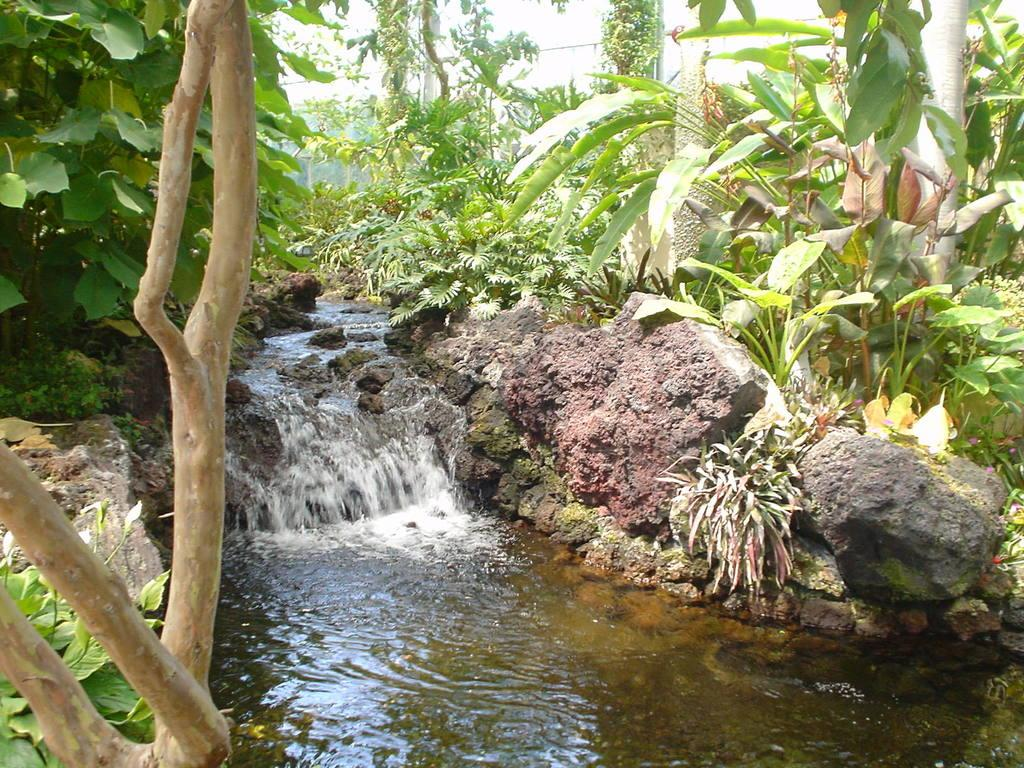What is the primary element visible in the image? There is water in the image. What type of vegetation can be seen in the image? There are plants and trees in the image. What other objects are present in the image? There are stones in the image. Where is the shirt hanging in the image? There is no shirt present in the image. What type of food can be cooked in the oven in the image? There is no oven present in the image. 